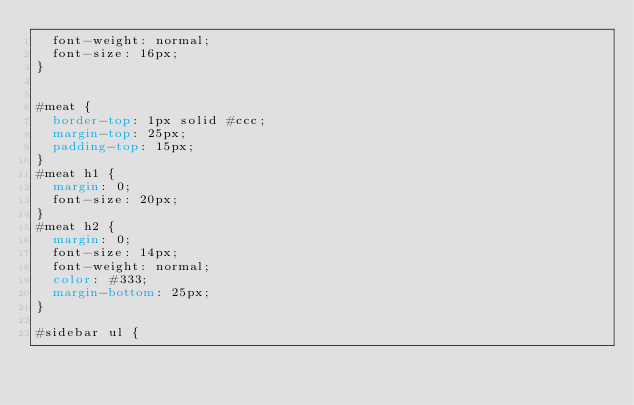Convert code to text. <code><loc_0><loc_0><loc_500><loc_500><_CSS_>  font-weight: normal;
  font-size: 16px;
}


#meat {
  border-top: 1px solid #ccc;
  margin-top: 25px;
  padding-top: 15px;
}
#meat h1 {
  margin: 0;
  font-size: 20px;
}
#meat h2 {
  margin: 0;
  font-size: 14px;
  font-weight: normal;
  color: #333;
  margin-bottom: 25px;
}

#sidebar ul {</code> 